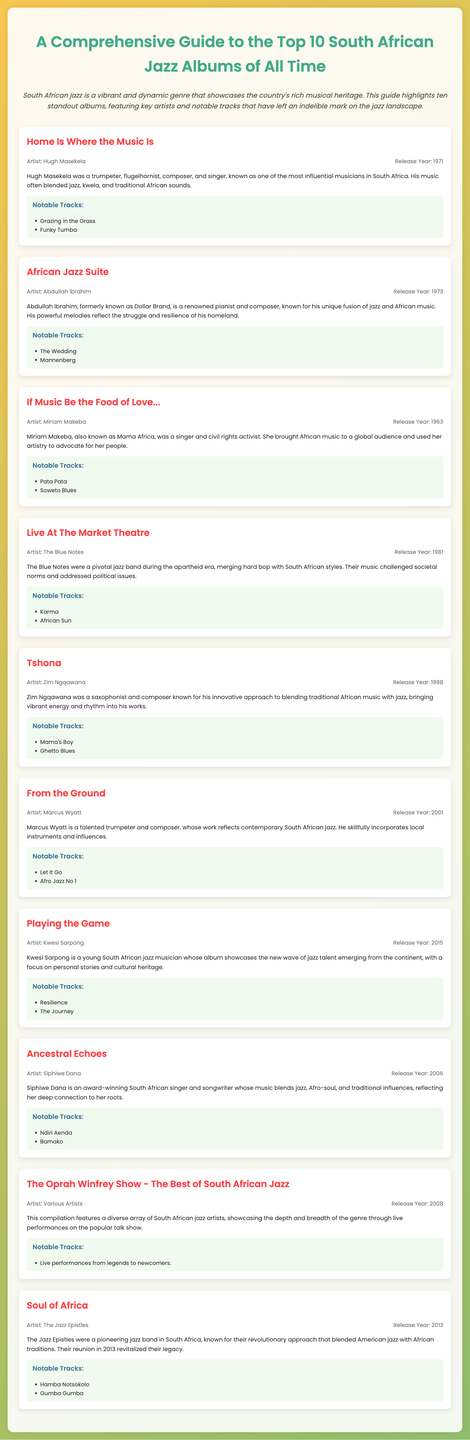What is the title of the first album listed? The title of the first album is featured at the top of the album list in the document.
Answer: Home Is Where the Music Is Who is the artist of the album "Mannenberg"? The artist's name is mentioned alongside the album title within the album entry.
Answer: Abdullah Ibrahim What year was "Pata Pata" released? The release year of "Pata Pata" can be found in the album entry for Miriam Makeba.
Answer: 1963 Which album was released in 2001? The albums are listed with their release years, allowing for identification of the 2001 release.
Answer: From the Ground Name one notable track from "Playing the Game". The document lists notable tracks for each album, including "Playing the Game".
Answer: Resilience Who is known as Mama Africa? The document identifies artists with their backgrounds, explicitly stating Miriam Makeba's nickname.
Answer: Miriam Makeba How many albums are listed in this guide? The document clearly states that it is a guide to the top 10 albums, indicating the count directly.
Answer: 10 What genre does Siphiwe Dana's music blend? The document describes the artist's work and specifies the genres she incorporates.
Answer: Jazz, Afro-soul, and traditional influences What significant event did The Blue Notes contribute to? The background information for The Blue Notes highlights their role during a particular historical context.
Answer: The apartheid era 